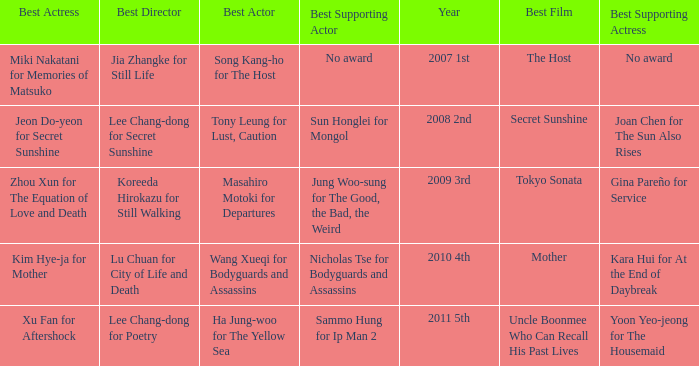Name the best actor for uncle boonmee who can recall his past lives Ha Jung-woo for The Yellow Sea. 